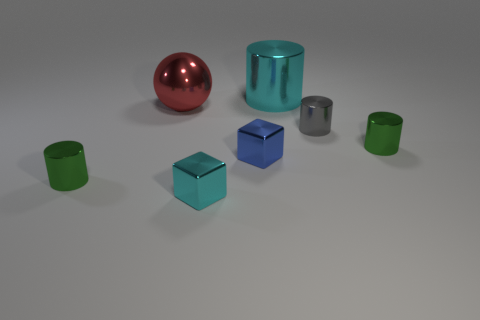There is a shiny thing that is on the left side of the big red shiny sphere; is it the same color as the small metallic thing on the right side of the small gray metal thing?
Give a very brief answer. Yes. What is the shape of the shiny thing that is the same color as the large cylinder?
Your answer should be very brief. Cube. Is there a tiny cyan rubber cylinder?
Provide a short and direct response. No. Is the number of cylinders behind the small cyan object greater than the number of small gray cylinders in front of the small blue shiny block?
Give a very brief answer. Yes. What is the color of the large object that is in front of the cyan thing that is behind the gray metal thing?
Your answer should be very brief. Red. Is there a thing of the same color as the big cylinder?
Offer a terse response. Yes. How big is the green cylinder right of the green object that is left of the shiny cylinder that is behind the gray cylinder?
Give a very brief answer. Small. There is a red metallic thing; what shape is it?
Keep it short and to the point. Sphere. There is a block that is the same color as the big metal cylinder; what is its size?
Provide a succinct answer. Small. How many tiny green metallic objects are to the right of the small cylinder on the right side of the tiny gray cylinder?
Give a very brief answer. 0. 